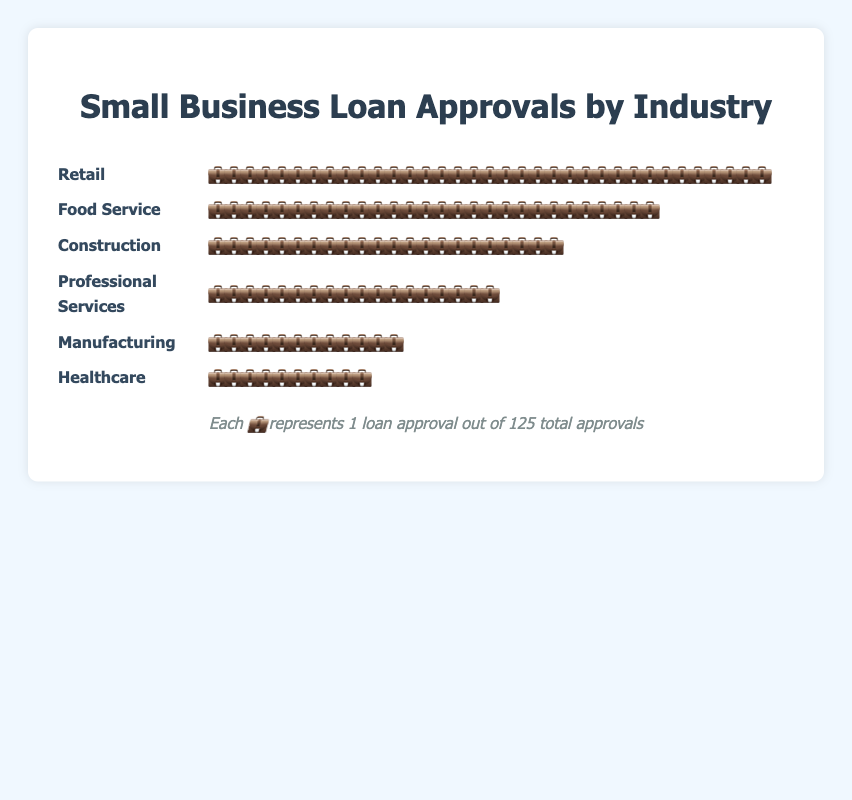What's the title of the figure? The title of the figure is placed at the top and center of the plot. It's typically styled in a larger and bolder font to facilitate easy identification.
Answer: "Small Business Loan Approvals by Industry" Which industry has the most loan approvals? By counting the icons (💼) next to each industry name, Retail has the most number of icons, indicating the most loan approvals.
Answer: Retail How many loan approvals are there in the Healthcare sector? The Healthcare sector has 10 icons of 💼, each representing one loan approval.
Answer: 10 What is the total number of loan approvals in the Construction and Food Service sectors combined? By adding 22 approvals from Construction and 28 from Food Service, we get the total number of approvals for these two sectors.
Answer: 50 Which industry has fewer loan approvals than Professional Services but more than Healthcare? Professional Services has 18 approvals and Healthcare has 10. Manufacturing falls in between with 12 approvals.
Answer: Manufacturing How do the Retail and Professional Services sectors compare in terms of loan approvals? Retail has 35 loan approvals, while Professional Services has 18. Retail has significantly more approvals than Professional Services.
Answer: Retail has more approvals than Professional Services What's the combined total of loan approvals for the top three industries? The top three industries in terms of loan approvals are Retail (35), Food Service (28), and Construction (22). Adding them together gives the combined total.
Answer: 85 What is the difference in loan approvals between the Construction and Manufacturing sectors? Construction has 22 loan approvals and Manufacturing has 12. The difference is 22 - 12.
Answer: 10 Which industry has the fewest loan approvals and how many? By counting the icons for each industry, Healthcare has the fewest loan approvals with a total of 10.
Answer: Healthcare, 10 How does the total number of loan approvals in Professional Services compare to the average number of approvals across all industries? The average can be calculated by dividing the total approvals (125) by the number of industries (6), which is approximately 20.83. Professional Services has 18, which is less than the average.
Answer: Less than the average 